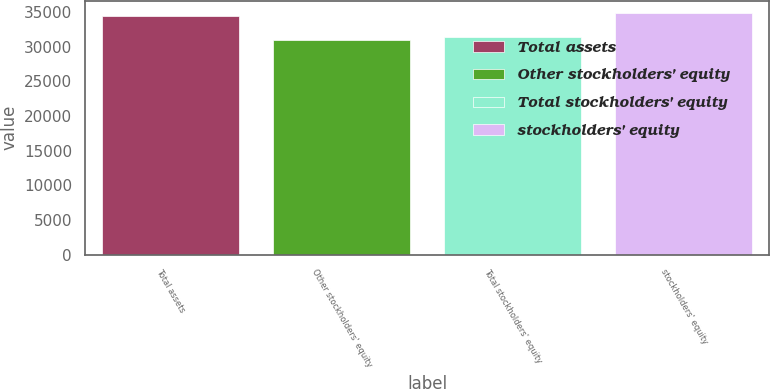Convert chart. <chart><loc_0><loc_0><loc_500><loc_500><bar_chart><fcel>Total assets<fcel>Other stockholders' equity<fcel>Total stockholders' equity<fcel>stockholders' equity<nl><fcel>34514<fcel>30990<fcel>31342.4<fcel>34866.4<nl></chart> 